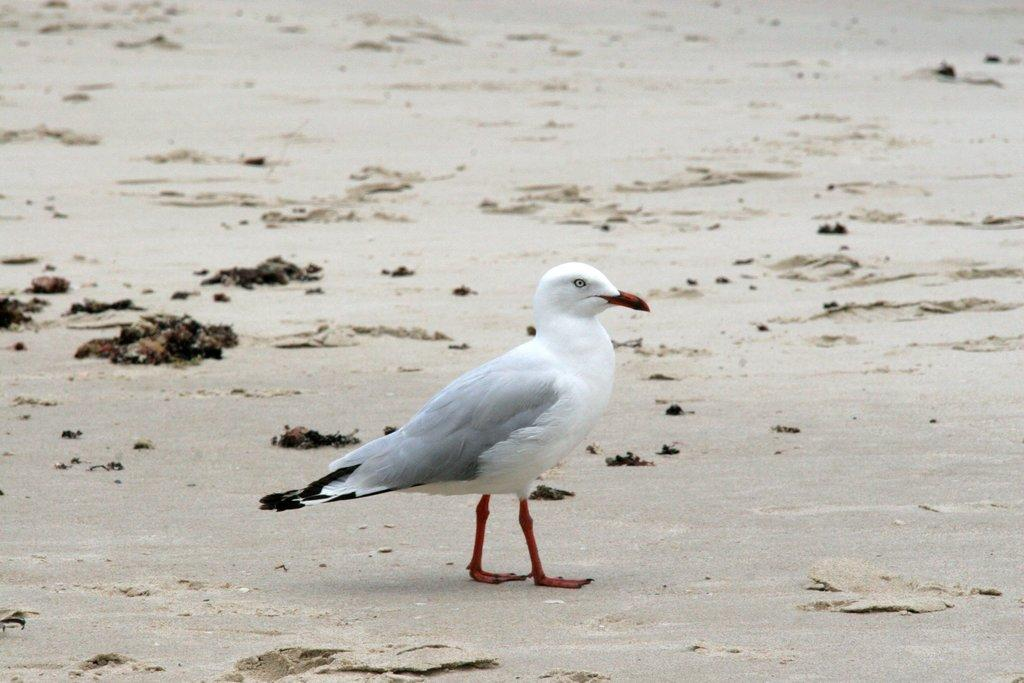Who is present in the image? There is a guy in the image. What is the guy standing on? The guy is standing on the sand. What type of button is the guy wearing on his shirt in the image? There is no button visible on the guy's shirt in the image. Is there a sofa present in the image? No, there is no sofa present in the image; the guy is standing on the sand. 